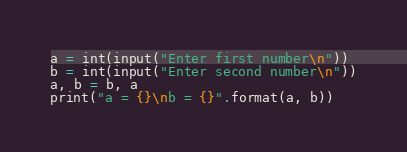<code> <loc_0><loc_0><loc_500><loc_500><_Python_>a = int(input("Enter first number\n"))
b = int(input("Enter second number\n"))
a, b = b, a
print("a = {}\nb = {}".format(a, b))</code> 